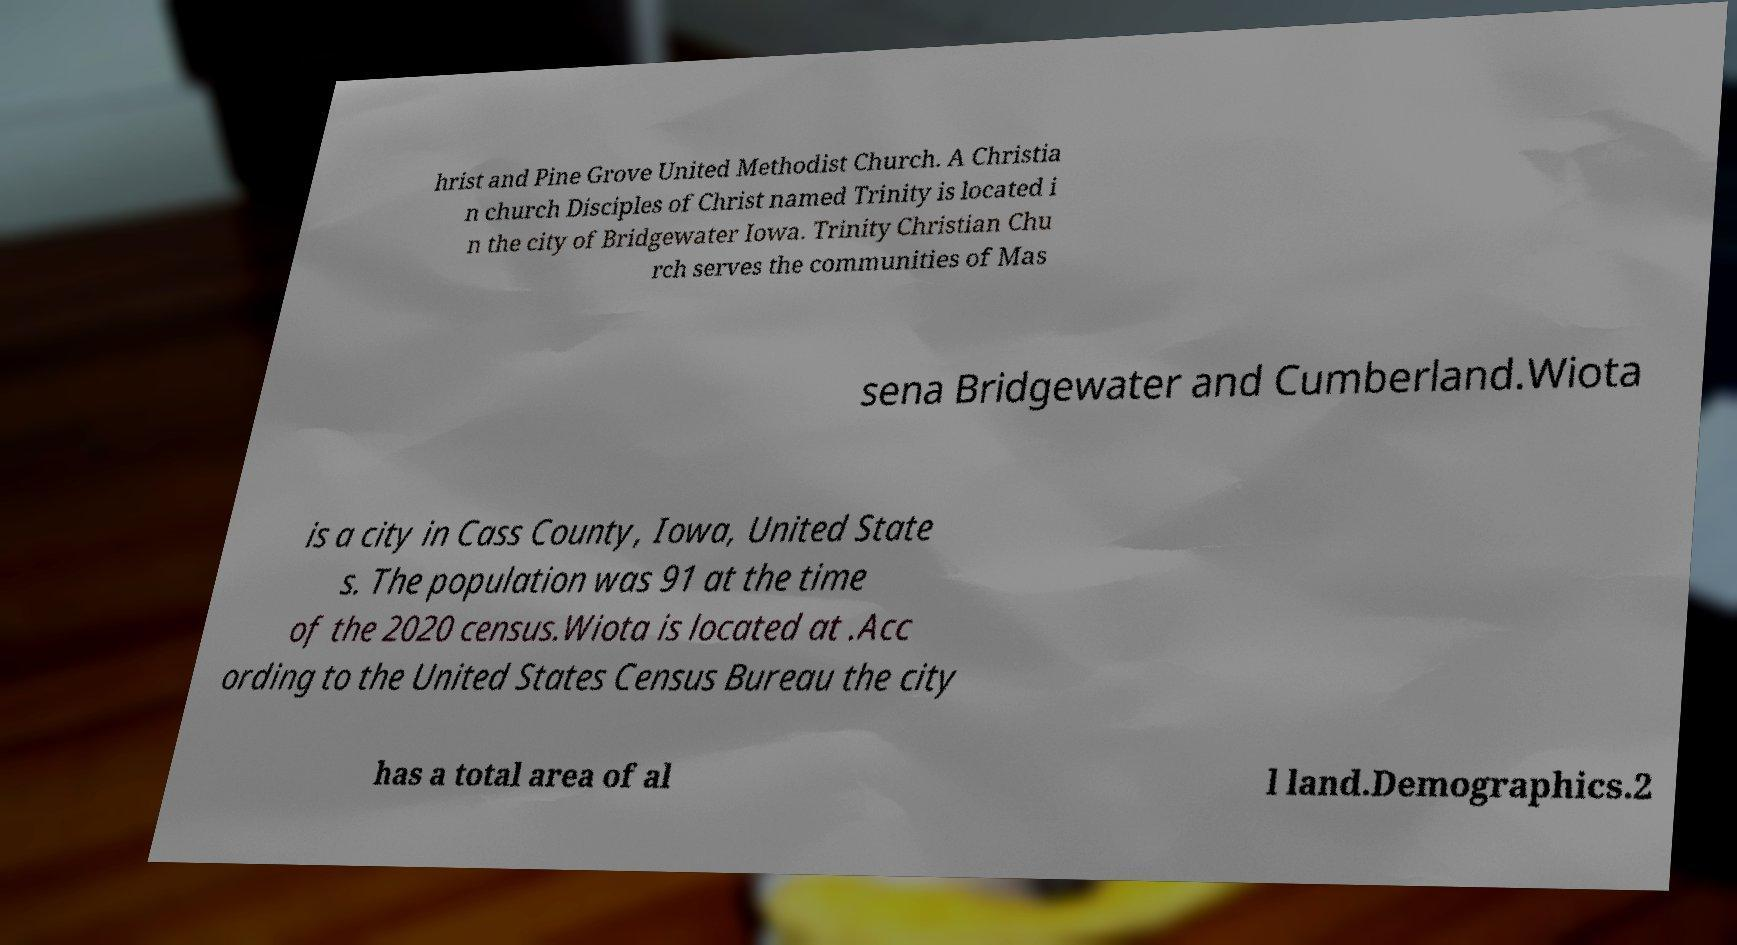Please read and relay the text visible in this image. What does it say? hrist and Pine Grove United Methodist Church. A Christia n church Disciples of Christ named Trinity is located i n the city of Bridgewater Iowa. Trinity Christian Chu rch serves the communities of Mas sena Bridgewater and Cumberland.Wiota is a city in Cass County, Iowa, United State s. The population was 91 at the time of the 2020 census.Wiota is located at .Acc ording to the United States Census Bureau the city has a total area of al l land.Demographics.2 